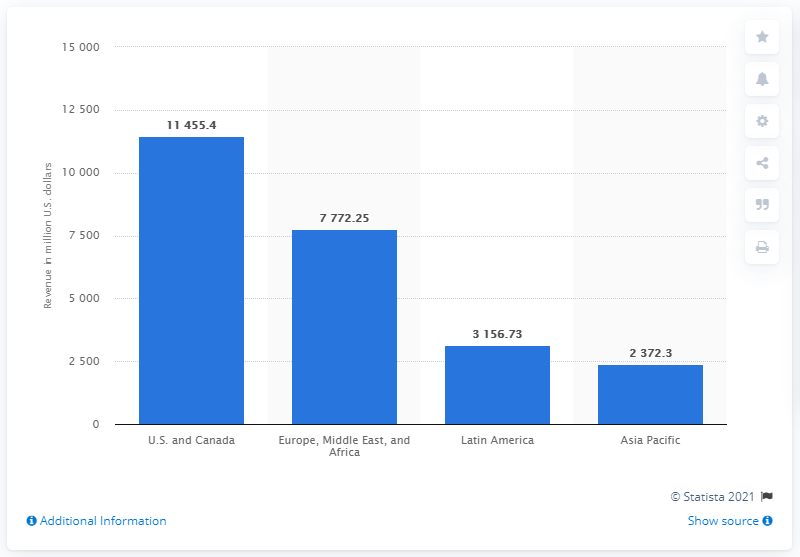Indicate a few pertinent items in this graphic. In 2020, the revenue generated from the Asia Pacific region was 11,455.4. In 2020, Netflix reported a total revenue of 11,455.4 million dollars in North America. There are currently two bars that are above 5000. Netflix's revenue in North America in the previous year was approximately 114,554.4.. The revenue of the region consisting of Europe, Middle East, and Africa is greater than the combined revenue of Latin America and Asia Pacific. 